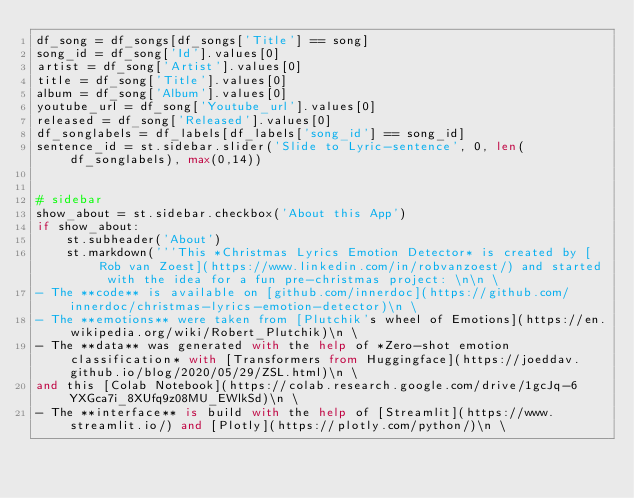<code> <loc_0><loc_0><loc_500><loc_500><_Python_>df_song = df_songs[df_songs['Title'] == song]
song_id = df_song['Id'].values[0]
artist = df_song['Artist'].values[0]
title = df_song['Title'].values[0]
album = df_song['Album'].values[0]
youtube_url = df_song['Youtube_url'].values[0]
released = df_song['Released'].values[0]
df_songlabels = df_labels[df_labels['song_id'] == song_id]
sentence_id = st.sidebar.slider('Slide to Lyric-sentence', 0, len(df_songlabels), max(0,14))


# sidebar
show_about = st.sidebar.checkbox('About this App')
if show_about:
    st.subheader('About')
    st.markdown('''This *Christmas Lyrics Emotion Detector* is created by [Rob van Zoest](https://www.linkedin.com/in/robvanzoest/) and started with the idea for a fun pre-christmas project: \n\n \
- The **code** is available on [github.com/innerdoc](https://github.com/innerdoc/christmas-lyrics-emotion-detector)\n \
- The **emotions** were taken from [Plutchik's wheel of Emotions](https://en.wikipedia.org/wiki/Robert_Plutchik)\n \
- The **data** was generated with the help of *Zero-shot emotion classification* with [Transformers from Huggingface](https://joeddav.github.io/blog/2020/05/29/ZSL.html)\n \
and this [Colab Notebook](https://colab.research.google.com/drive/1gcJq-6YXGca7i_8XUfq9z08MU_EWlkSd)\n \
- The **interface** is build with the help of [Streamlit](https://www.streamlit.io/) and [Plotly](https://plotly.com/python/)\n \</code> 